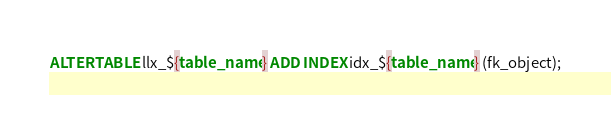Convert code to text. <code><loc_0><loc_0><loc_500><loc_500><_SQL_>
ALTER TABLE llx_${table_name} ADD INDEX idx_${table_name} (fk_object);
</code> 